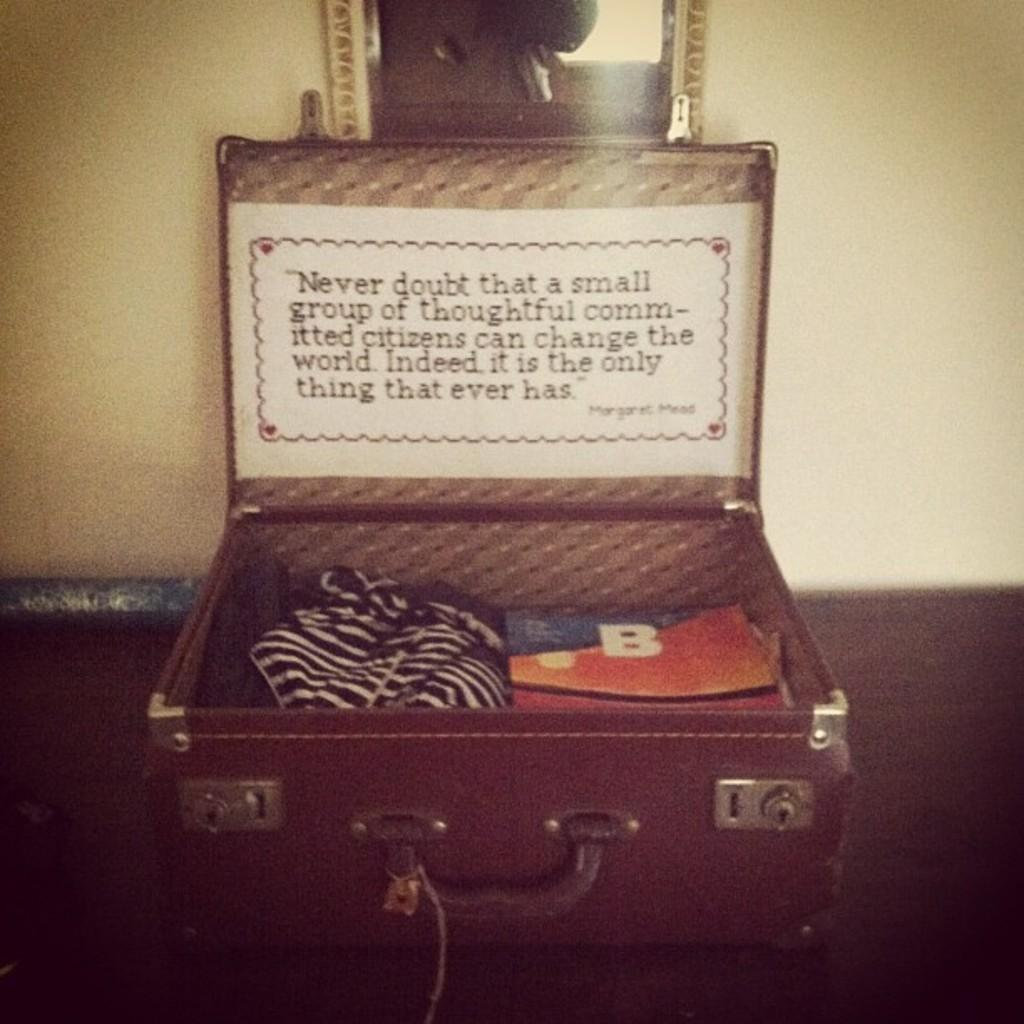What object in the image is typically used for carrying belongings? There is a suitcase in the image, which is typically used for carrying belongings. What items can be found inside the suitcase? The suitcase contains clothes and a purse. What is the purpose of the paper with writing on it in the image? The purpose of the paper with writing on it is not specified in the facts, but it may contain information, a list, or a note. What type of pancake is being used as a weapon in the image? There is no pancake present in the image, let alone one being used as a weapon. 